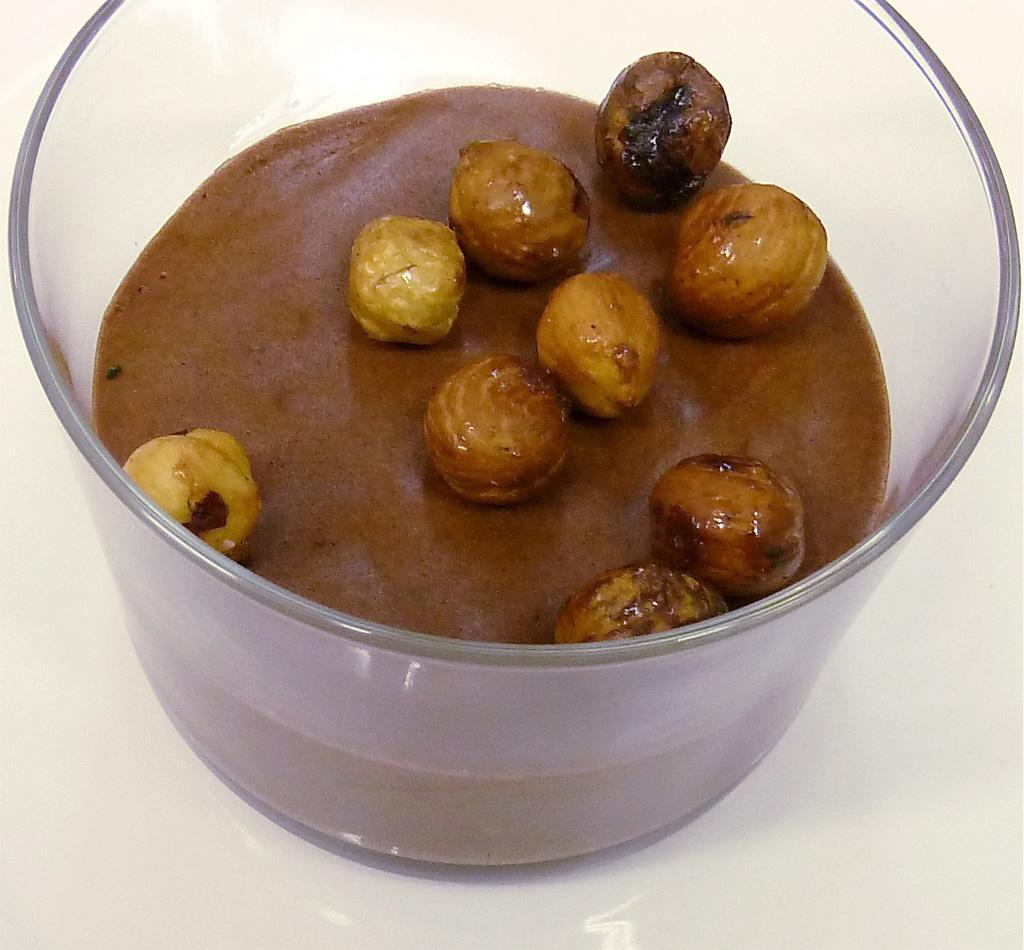Can you describe this image briefly? In this image I can see a glass bowl, in the bowl I can see food in brown color. 